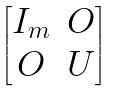<formula> <loc_0><loc_0><loc_500><loc_500>\begin{bmatrix} I _ { m } & O \\ O & U \end{bmatrix}</formula> 